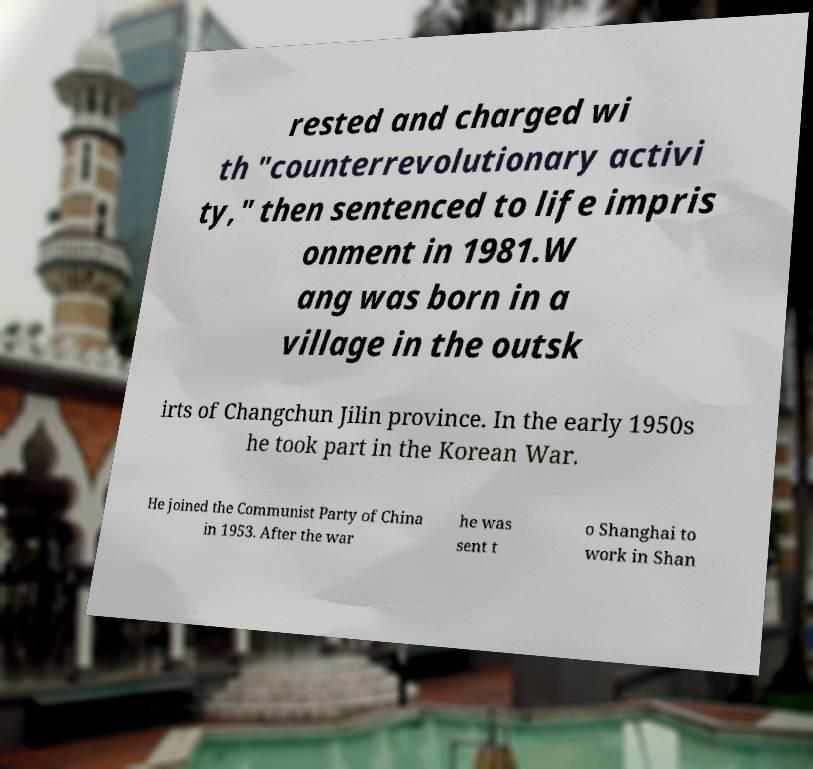Could you assist in decoding the text presented in this image and type it out clearly? rested and charged wi th "counterrevolutionary activi ty," then sentenced to life impris onment in 1981.W ang was born in a village in the outsk irts of Changchun Jilin province. In the early 1950s he took part in the Korean War. He joined the Communist Party of China in 1953. After the war he was sent t o Shanghai to work in Shan 